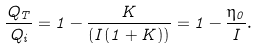<formula> <loc_0><loc_0><loc_500><loc_500>\frac { Q _ { T } } { Q _ { i } } = 1 - \frac { K } { ( I ( 1 + K ) ) } = 1 - \frac { \eta _ { 0 } } { I } .</formula> 